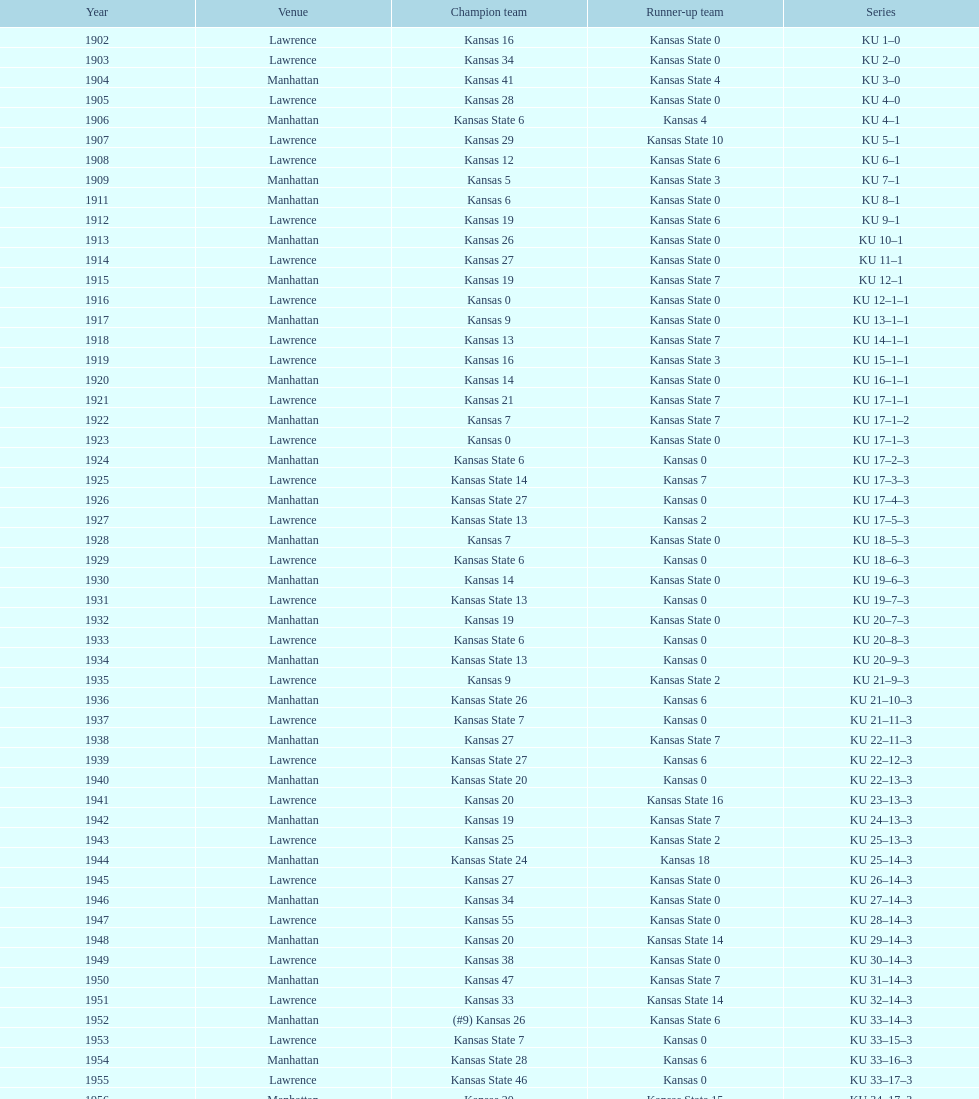Before 1950 what was the most points kansas scored? 55. 